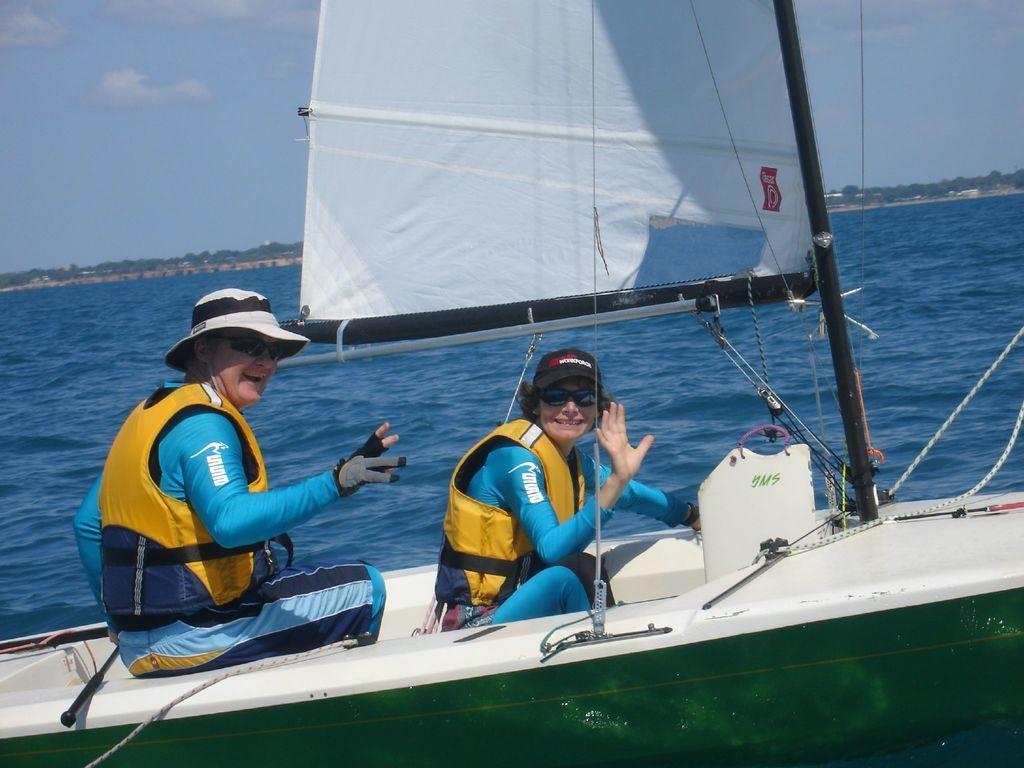Could you give a brief overview of what you see in this image? In the center of the image there are two ladies sitting in a ship. In the background of the image there are trees,water,sky. 